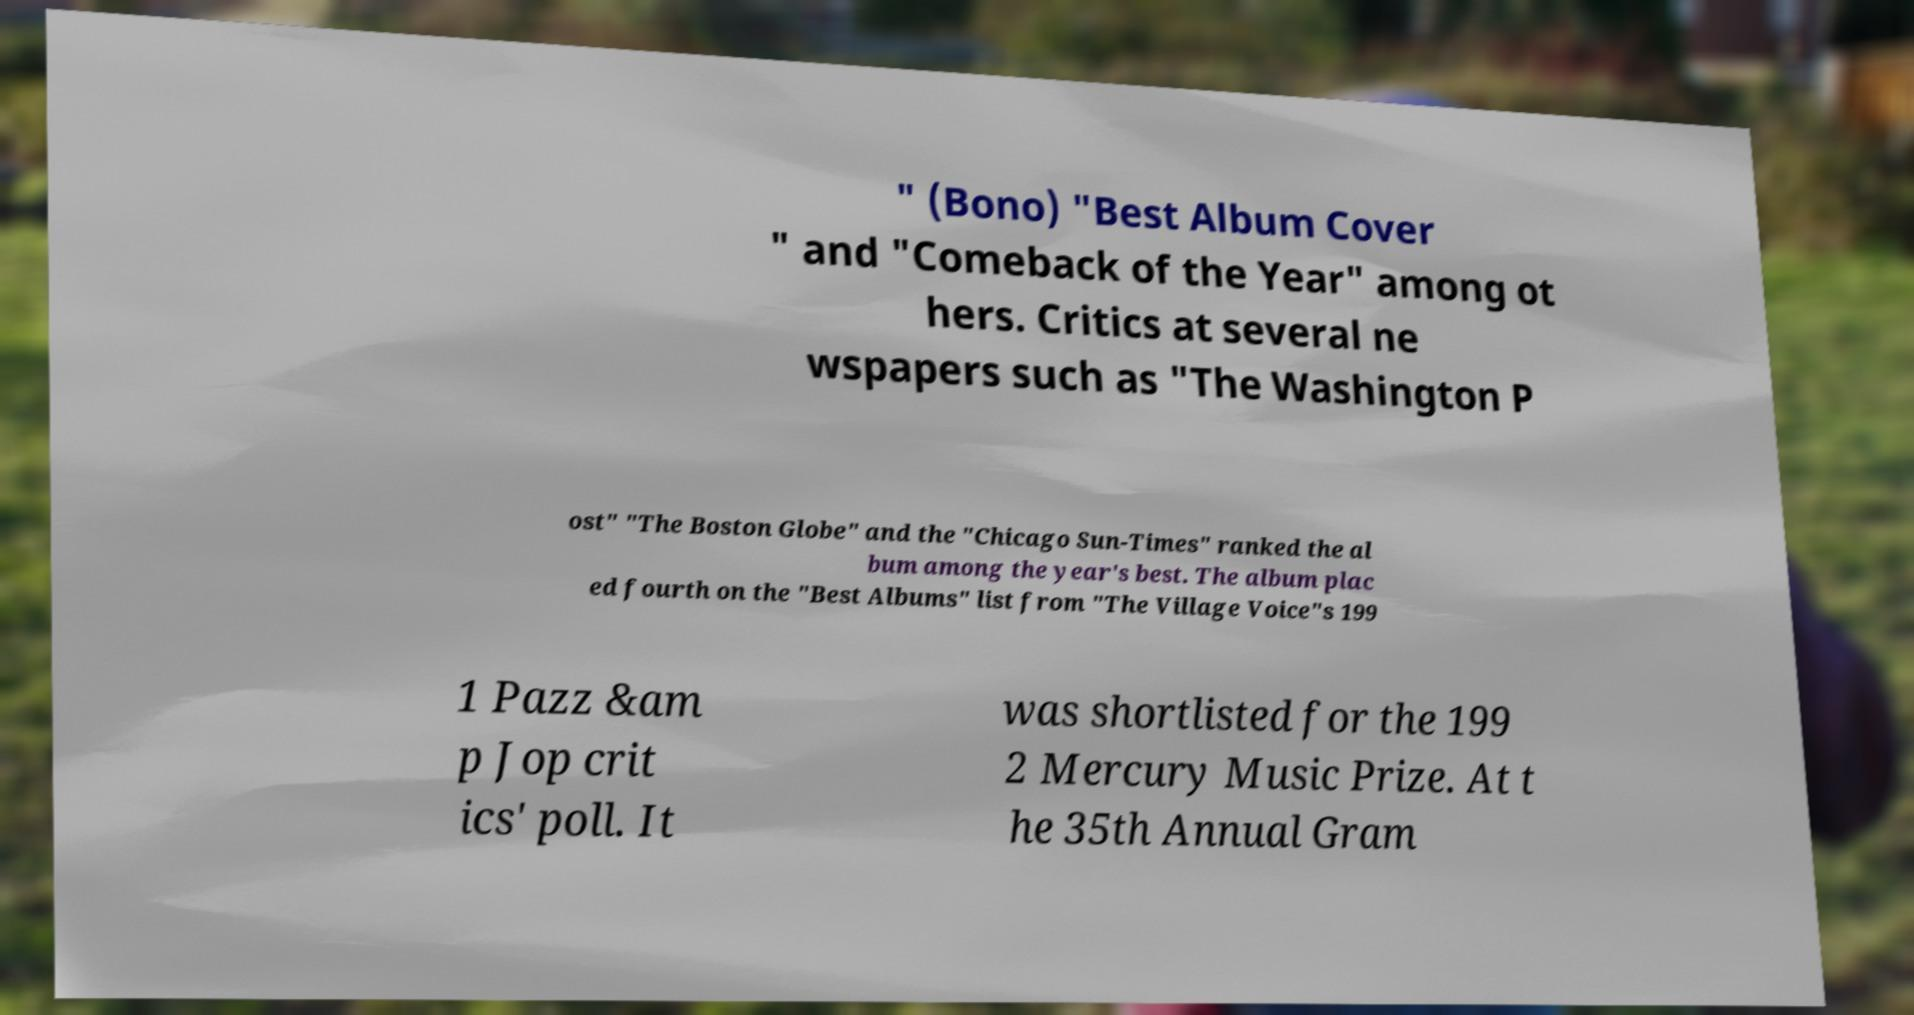What messages or text are displayed in this image? I need them in a readable, typed format. " (Bono) "Best Album Cover " and "Comeback of the Year" among ot hers. Critics at several ne wspapers such as "The Washington P ost" "The Boston Globe" and the "Chicago Sun-Times" ranked the al bum among the year's best. The album plac ed fourth on the "Best Albums" list from "The Village Voice"s 199 1 Pazz &am p Jop crit ics' poll. It was shortlisted for the 199 2 Mercury Music Prize. At t he 35th Annual Gram 